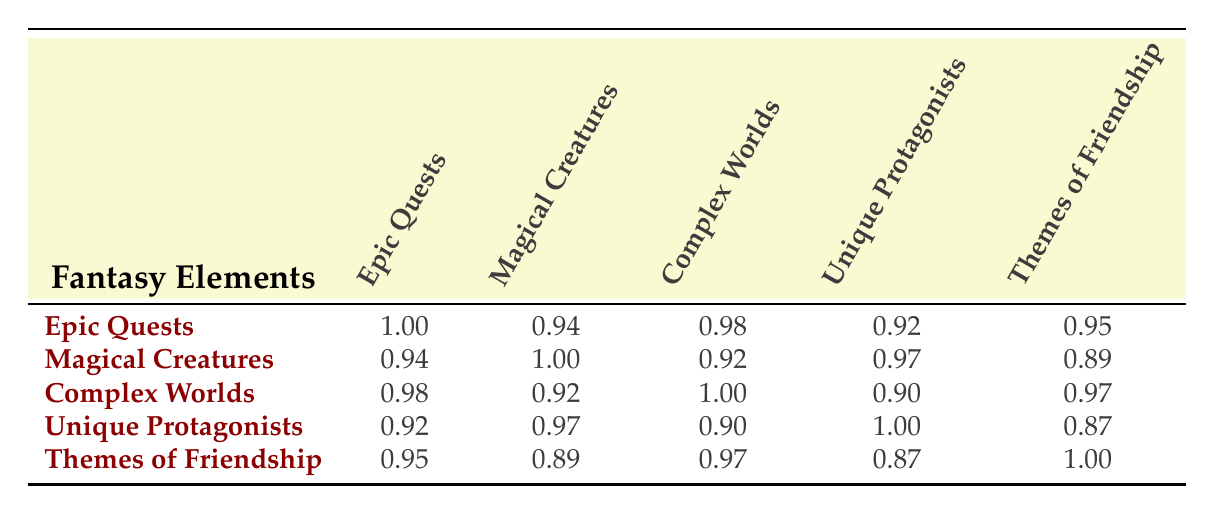What is the average success rate for the "Epic Quests" element? The average success rate for "Epic Quests" is provided in the table, which is listed as 85.
Answer: 85 Which fantasy element has the highest average success rate? By comparing the average success rates of all elements, "Themes of Friendship" has the highest average success rate of 90.
Answer: 90 What is the adaptation success rate for the "Alice in Wonderland"? The adaptation success rate for "Alice in Wonderland" is mentioned in the "Magical Creatures" category, which is 70.
Answer: 70 Is the adaptation success rate of "The Dark Tower" higher than that of "His Dark Materials"? The adaptation success rate of "The Dark Tower" is 55, while "His Dark Materials" has a success rate of 75. Since 55 is less than 75, the statement is false.
Answer: No What is the correlation between "Epic Quests" and "Themes of Friendship"? The table shows the correlation between "Epic Quests" and "Themes of Friendship" is 0.95, indicating a strong positive correlation.
Answer: 0.95 What is the difference in average success rates between "Magical Creatures" and "Unique Protagonists"? The average success rate for "Magical Creatures" is 80, and for "Unique Protagonists," it is 78. The difference is 80 - 78 = 2.
Answer: 2 Which fantasy element is least correlated with "Themes of Friendship"? From the table, the element least correlated with "Themes of Friendship" is "Unique Protagonists," with a correlation of 0.87.
Answer: Unique Protagonists If you combine the adaptation success rates of "Percy Jackson" and "Fantastic Beasts," what is the total? "Percy Jackson" has an adaptation success rate of 60, and "Fantastic Beasts" has 75. The total is 60 + 75 = 135.
Answer: 135 What are the adaptation success rates of the works under the "Complex Worlds" category? The adaptation success rates under "Complex Worlds" are listed as 95 for "A Song of Ice and Fire," 80 for "Narnia Series," and 55 for "The Dark Tower."
Answer: 95, 80, 55 